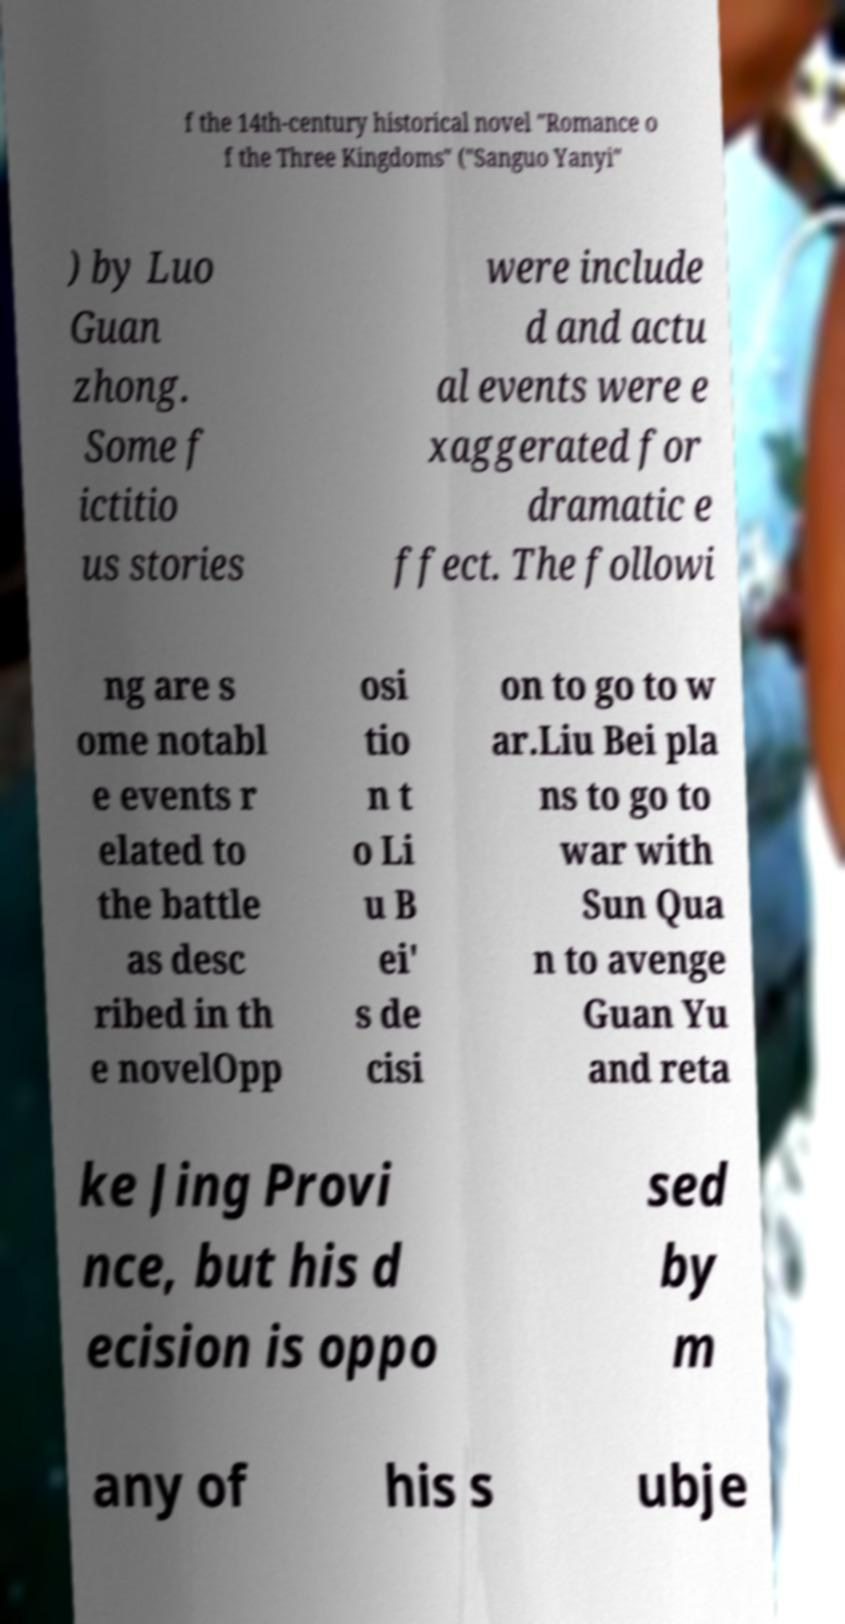Please read and relay the text visible in this image. What does it say? f the 14th-century historical novel "Romance o f the Three Kingdoms" ("Sanguo Yanyi" ) by Luo Guan zhong. Some f ictitio us stories were include d and actu al events were e xaggerated for dramatic e ffect. The followi ng are s ome notabl e events r elated to the battle as desc ribed in th e novelOpp osi tio n t o Li u B ei' s de cisi on to go to w ar.Liu Bei pla ns to go to war with Sun Qua n to avenge Guan Yu and reta ke Jing Provi nce, but his d ecision is oppo sed by m any of his s ubje 